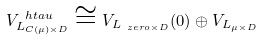Convert formula to latex. <formula><loc_0><loc_0><loc_500><loc_500>V _ { L _ { C ( \mu ) \times D } } ^ { \ h t a u } \cong V _ { L _ { \ z e r o \times D } } ( 0 ) \oplus V _ { L _ { \mu \times D } }</formula> 